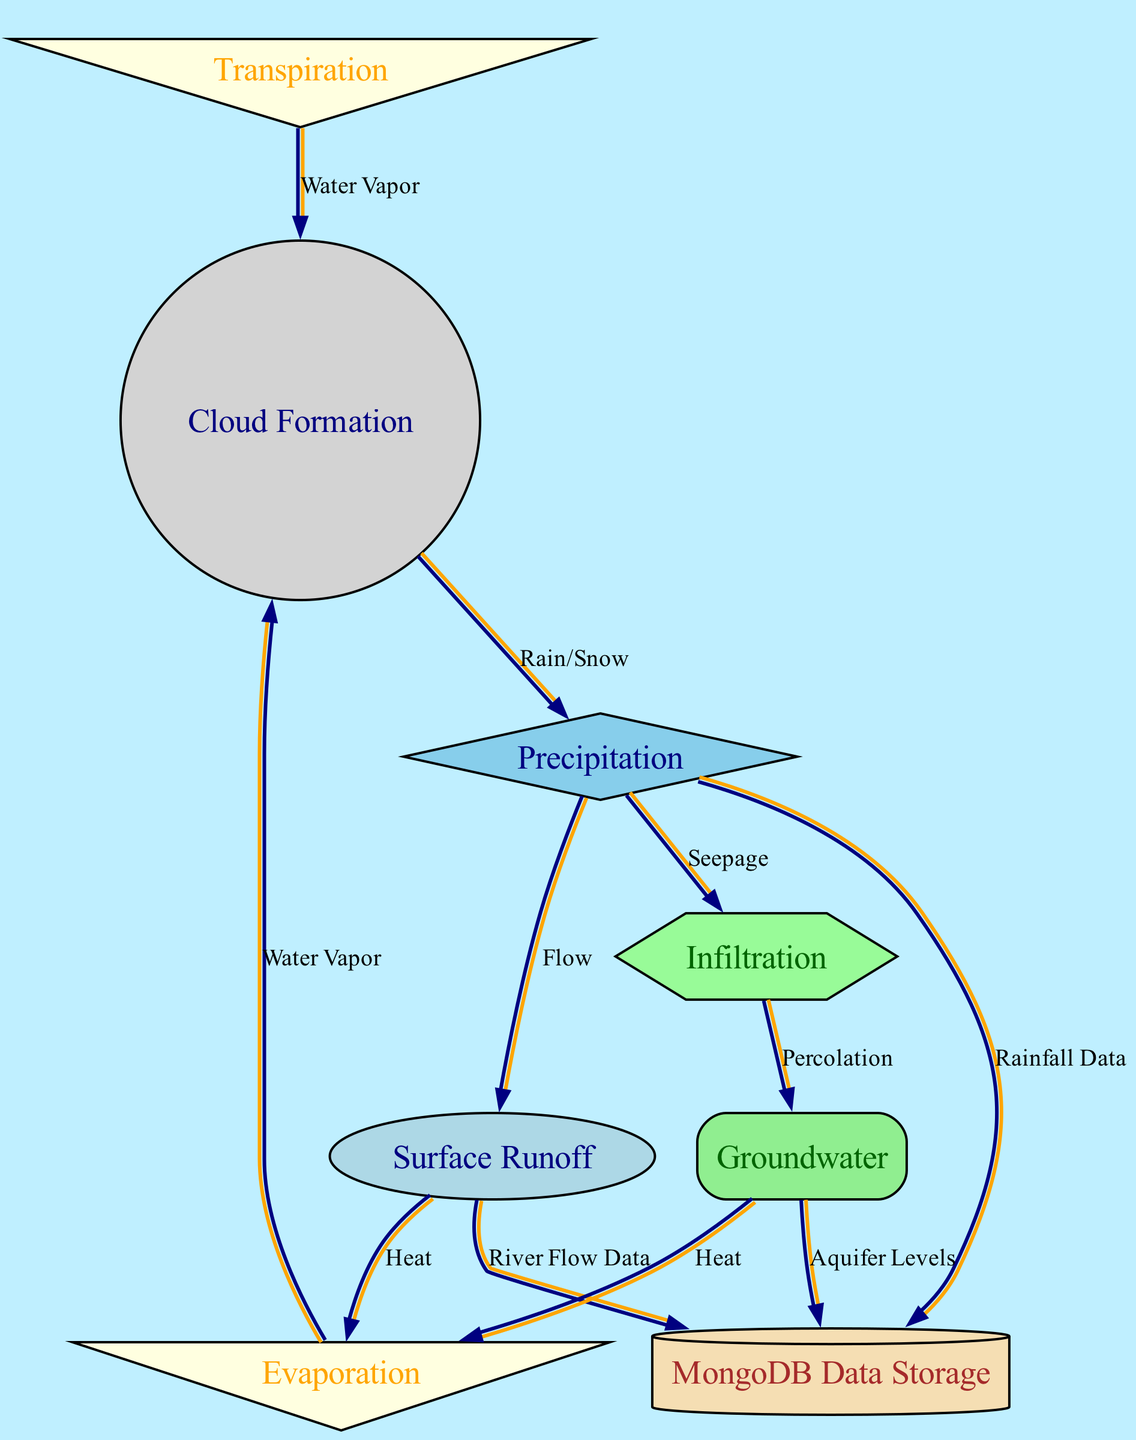What is the starting point of the water cycle? The diagram shows that "Cloud Formation" is the node from which other processes are initiated, indicating that this is the starting point of the water cycle.
Answer: Cloud Formation How many types of data collection points are there? The diagram includes three data collection points: "Rainfall Data," "River Flow Data," and "Aquifer Levels." Therefore, there are three types of data collection points.
Answer: 3 What process occurs right after precipitation? According to the diagram, "Surface Runoff" and "Infiltration" are both connected to "Precipitation," indicating these processes occur next in the cycle.
Answer: Surface Runoff and Infiltration What is the relationship between groundwater and evaporation? The diagram shows arrows from "Groundwater" to "Evaporation" labeled "Heat," indicating that groundwater contributes to evaporation through heat transfer.
Answer: Heat What is the final step that leads water back to clouds? The diagram indicates that both "Evaporation" and "Transpiration" contribute water vapor back into "Cloud Formation," illustrating that this is the final step leading back to clouds.
Answer: Water Vapor Which node is represented as a cylinder in the diagram? The diagram specifically depicts "MongoDB Data Storage" as a cylinder shape, signifying its representation in the diagram.
Answer: MongoDB Data Storage How many edges connect to the runoff node? The diagram indicates that there are three edges connected to "Surface Runoff" leading to "Evaporation," "River Flow Data," and from "Precipitation." Thus, there are three edges connected to this node.
Answer: 3 Which two nodes are involved in the process of percolation? The diagram indicates that "Infiltration" leads to "Groundwater" through the process labeled "Percolation," linking these two nodes.
Answer: Infiltration and Groundwater What is the function of transpiration in the water cycle? In the diagram, "Transpiration" is actively contributing "Water Vapor" back to "Cloud Formation," indicating its role in the water cycle by returning moisture to the atmosphere.
Answer: Water Vapor 